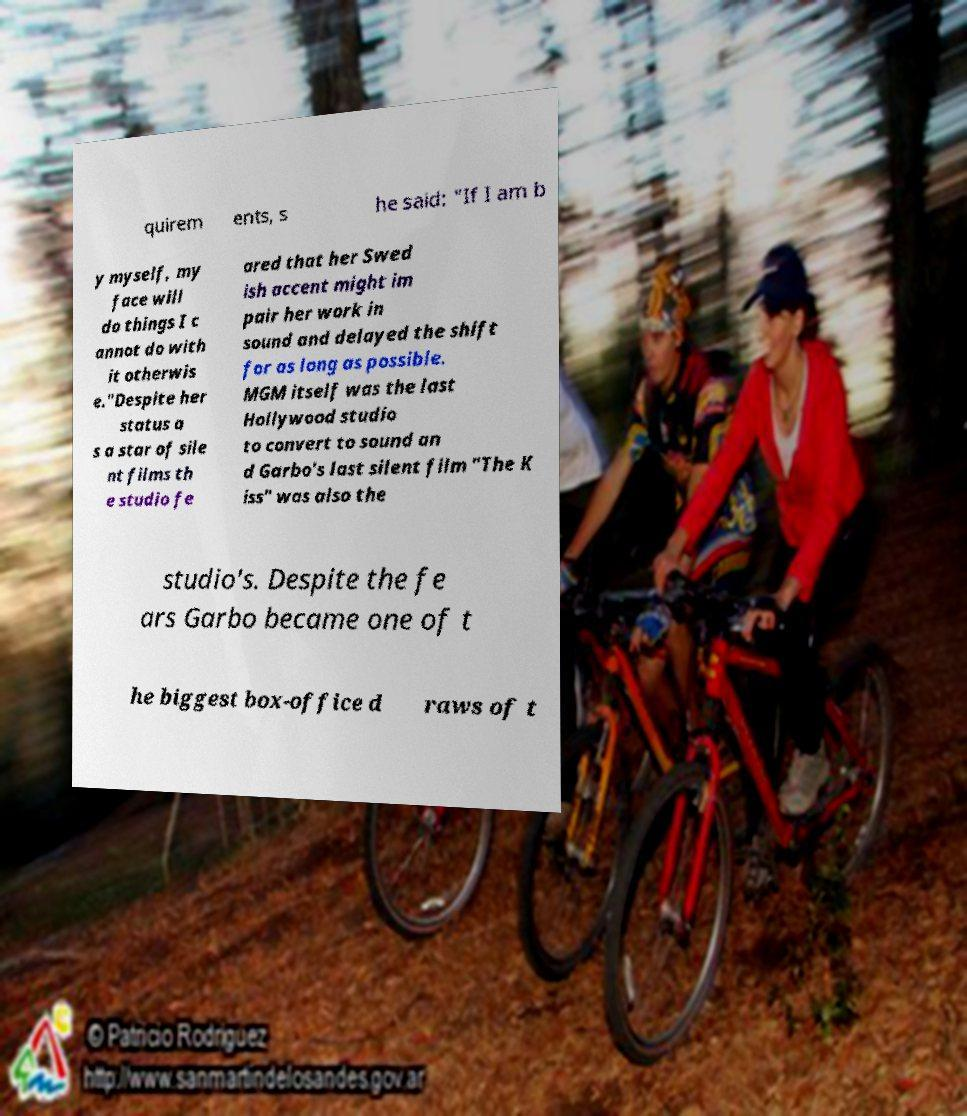I need the written content from this picture converted into text. Can you do that? quirem ents, s he said: "If I am b y myself, my face will do things I c annot do with it otherwis e."Despite her status a s a star of sile nt films th e studio fe ared that her Swed ish accent might im pair her work in sound and delayed the shift for as long as possible. MGM itself was the last Hollywood studio to convert to sound an d Garbo's last silent film "The K iss" was also the studio's. Despite the fe ars Garbo became one of t he biggest box-office d raws of t 